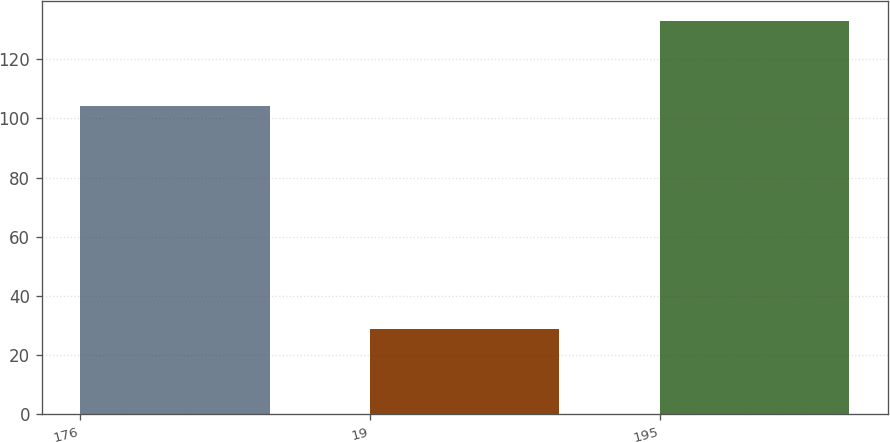<chart> <loc_0><loc_0><loc_500><loc_500><bar_chart><fcel>176<fcel>19<fcel>195<nl><fcel>104<fcel>29<fcel>133<nl></chart> 